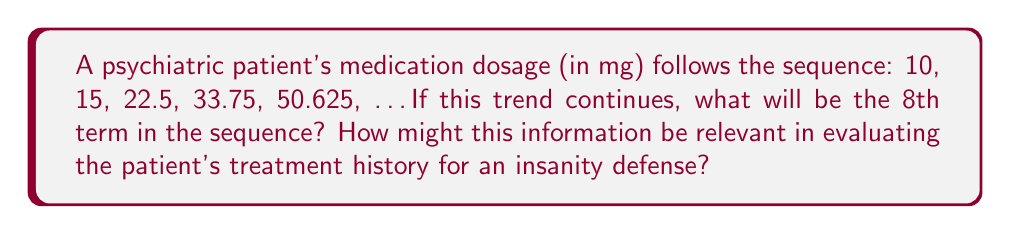Teach me how to tackle this problem. To solve this problem, we need to identify the pattern in the sequence and extend it to the 8th term. Let's break it down step-by-step:

1) First, let's examine the ratio between consecutive terms:

   $\frac{15}{10} = 1.5$
   $\frac{22.5}{15} = 1.5$
   $\frac{33.75}{22.5} = 1.5$
   $\frac{50.625}{33.75} = 1.5$

2) We can see that each term is 1.5 times the previous term. This is a geometric sequence with a common ratio of 1.5.

3) The general term for a geometric sequence is given by:

   $a_n = a_1 \cdot r^{n-1}$

   Where $a_n$ is the nth term, $a_1$ is the first term, r is the common ratio, and n is the position of the term.

4) In this case, $a_1 = 10$ and $r = 1.5$

5) To find the 8th term, we substitute $n = 8$ into the formula:

   $a_8 = 10 \cdot 1.5^{8-1} = 10 \cdot 1.5^7$

6) Calculate:
   
   $a_8 = 10 \cdot 1.5^7 = 10 \cdot 17.0859375 = 170.859375$

7) Rounding to 3 decimal places: 170.859 mg

This rapid increase in dosage over time could be crucial evidence in an insanity defense. It might indicate escalating symptoms requiring stronger medication, potential medication resistance, or improper treatment, all of which could support arguments about the defendant's mental state at the time of the alleged crime.
Answer: 170.859 mg 